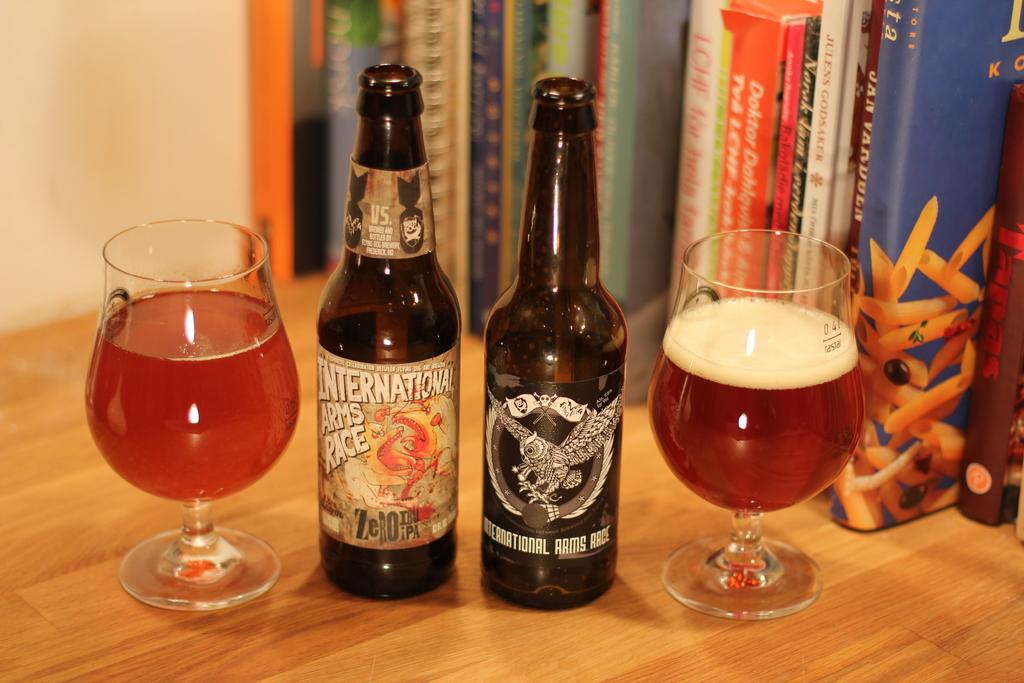What type of objects can be seen in the image? There are glasses, bottles, and books in the image. What might be used for drinking or holding liquids in the image? The glasses and bottles in the image can be used for drinking or holding liquids. What type of items are present for reading or learning? The books in the image can be used for reading or learning. What is the color of the surface in the image? The surface in the image is brown. What is visible in the background of the image? There is a wall visible in the image. How many ants can be seen climbing the hill in the image? There are no ants or hills present in the image. What type of seat is visible in the image? There is no seat visible in the image. 